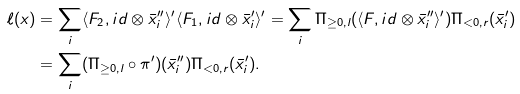<formula> <loc_0><loc_0><loc_500><loc_500>\ell ( x ) & = \sum _ { i } \langle F _ { 2 } , i d \otimes \bar { x } ^ { \prime \prime } _ { i } \rangle ^ { \prime } \langle F _ { 1 } , i d \otimes \bar { x } ^ { \prime } _ { i } \rangle ^ { \prime } = \sum _ { i } \Pi _ { \geq 0 , l } ( \langle F , i d \otimes \bar { x } ^ { \prime \prime } _ { i } \rangle ^ { \prime } ) \Pi _ { < 0 , r } ( \bar { x } ^ { \prime } _ { i } ) \\ & = \sum _ { i } ( \Pi _ { \geq 0 , l } \circ \pi ^ { \prime } ) ( \bar { x } ^ { \prime \prime } _ { i } ) \Pi _ { < 0 , r } ( \bar { x } ^ { \prime } _ { i } ) .</formula> 